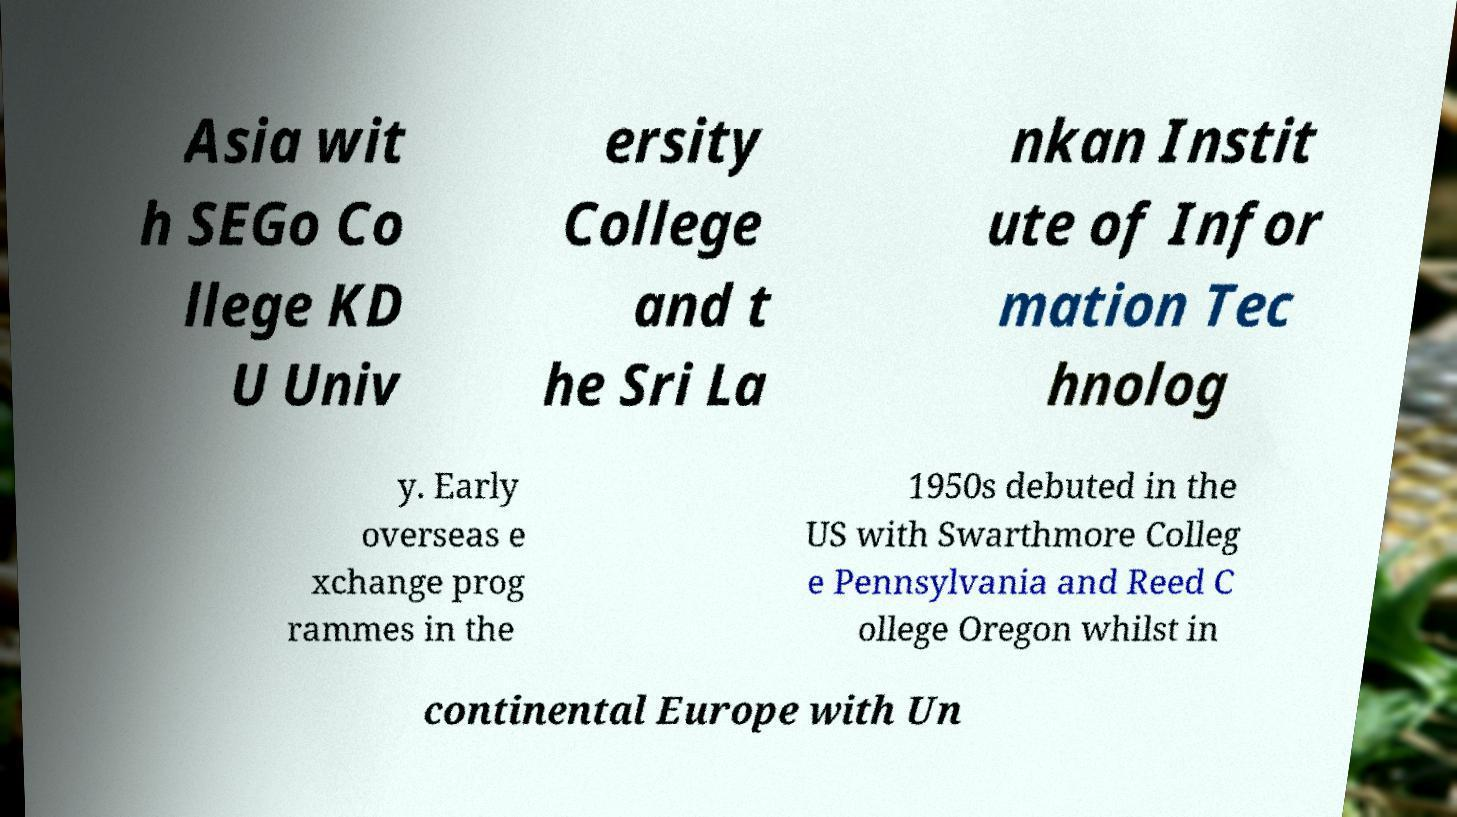What messages or text are displayed in this image? I need them in a readable, typed format. Asia wit h SEGo Co llege KD U Univ ersity College and t he Sri La nkan Instit ute of Infor mation Tec hnolog y. Early overseas e xchange prog rammes in the 1950s debuted in the US with Swarthmore Colleg e Pennsylvania and Reed C ollege Oregon whilst in continental Europe with Un 